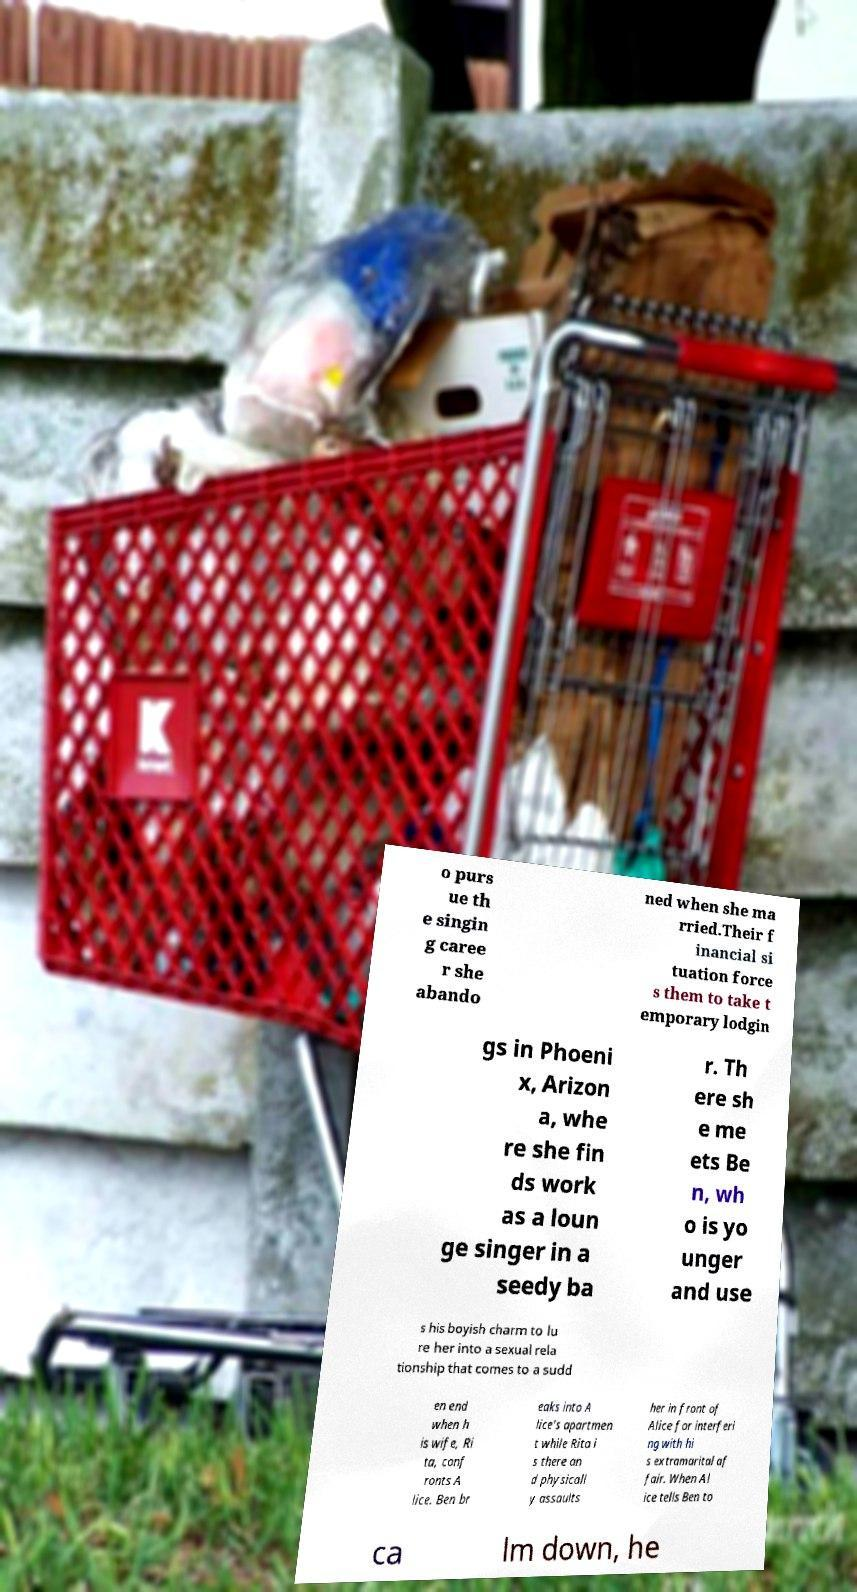Please read and relay the text visible in this image. What does it say? o purs ue th e singin g caree r she abando ned when she ma rried.Their f inancial si tuation force s them to take t emporary lodgin gs in Phoeni x, Arizon a, whe re she fin ds work as a loun ge singer in a seedy ba r. Th ere sh e me ets Be n, wh o is yo unger and use s his boyish charm to lu re her into a sexual rela tionship that comes to a sudd en end when h is wife, Ri ta, conf ronts A lice. Ben br eaks into A lice's apartmen t while Rita i s there an d physicall y assaults her in front of Alice for interferi ng with hi s extramarital af fair. When Al ice tells Ben to ca lm down, he 